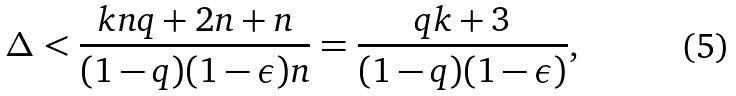Convert formula to latex. <formula><loc_0><loc_0><loc_500><loc_500>\Delta < \frac { k n q + 2 n + n } { ( 1 - q ) ( 1 - \epsilon ) n } = \frac { q k + 3 } { ( 1 - q ) ( 1 - \epsilon ) } ,</formula> 